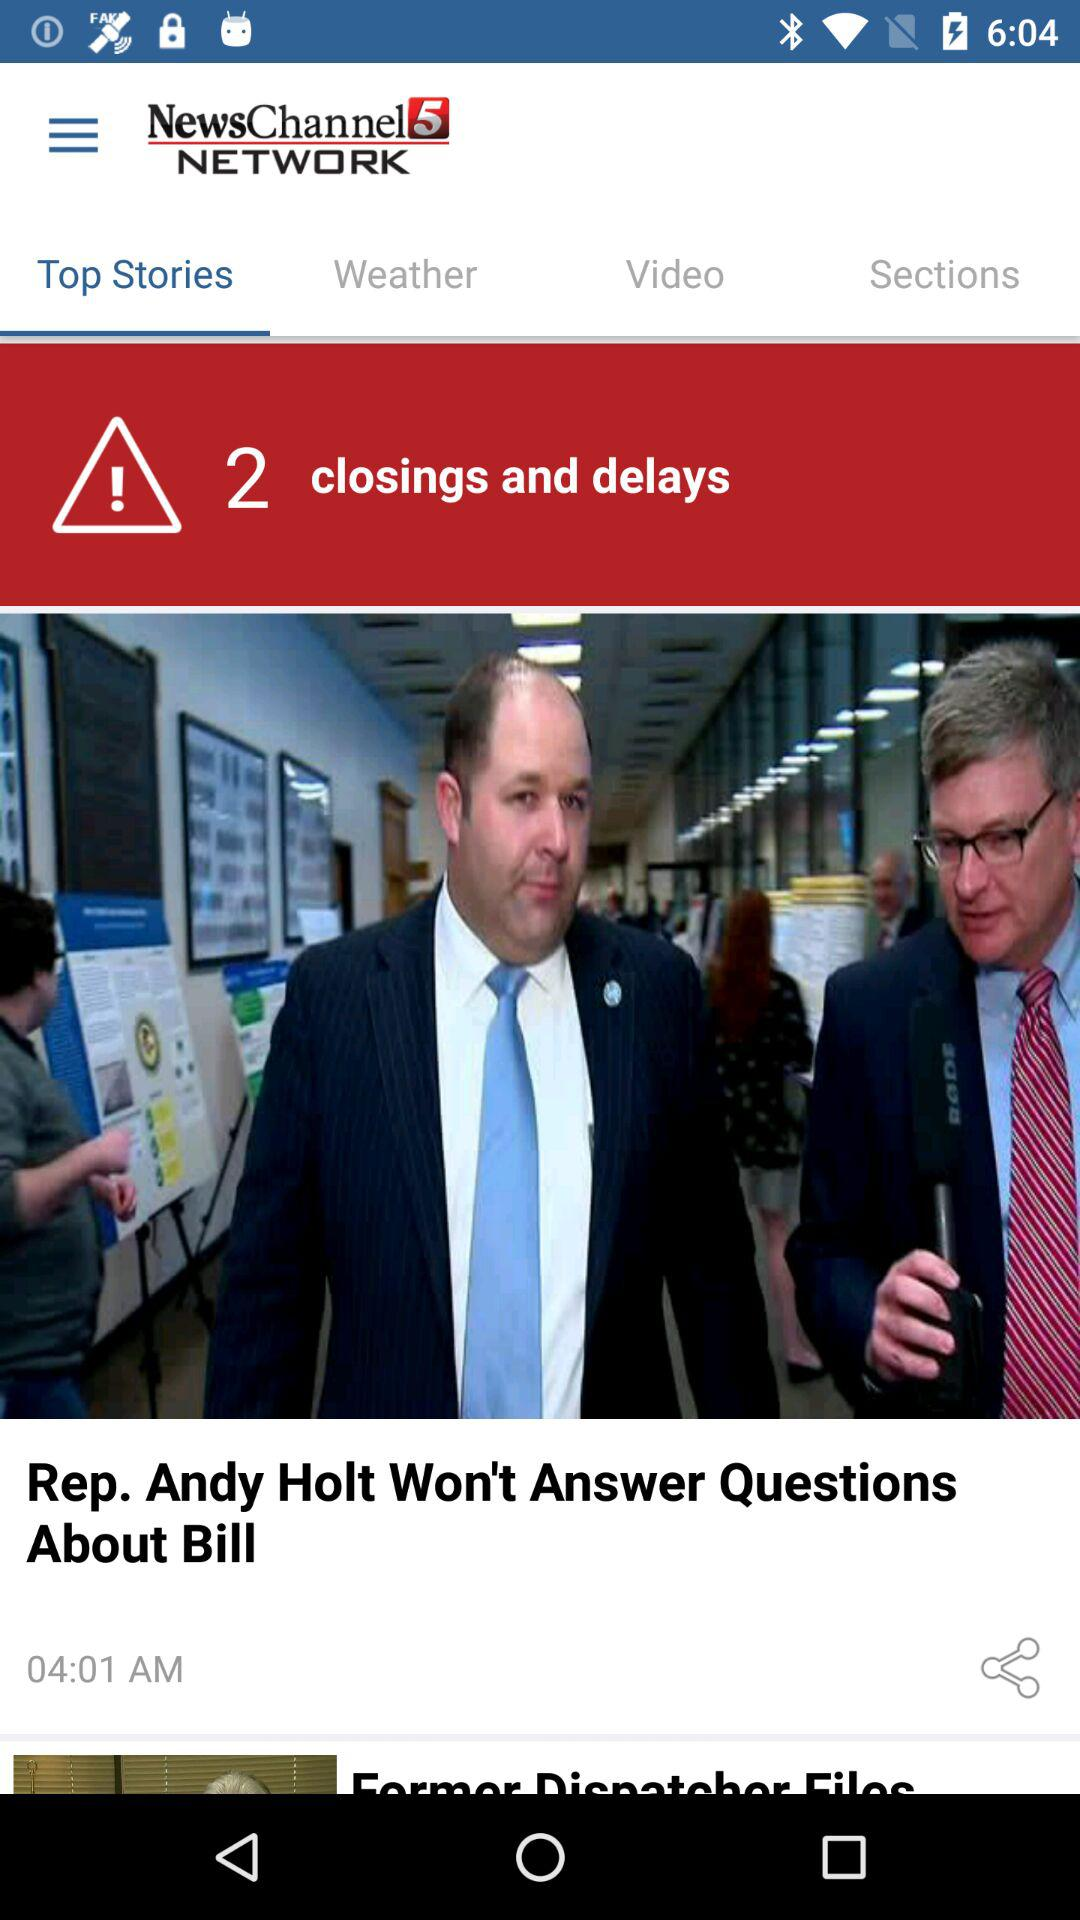What's the total number of closing and delays stories? There are 2 closing and delays stories. 